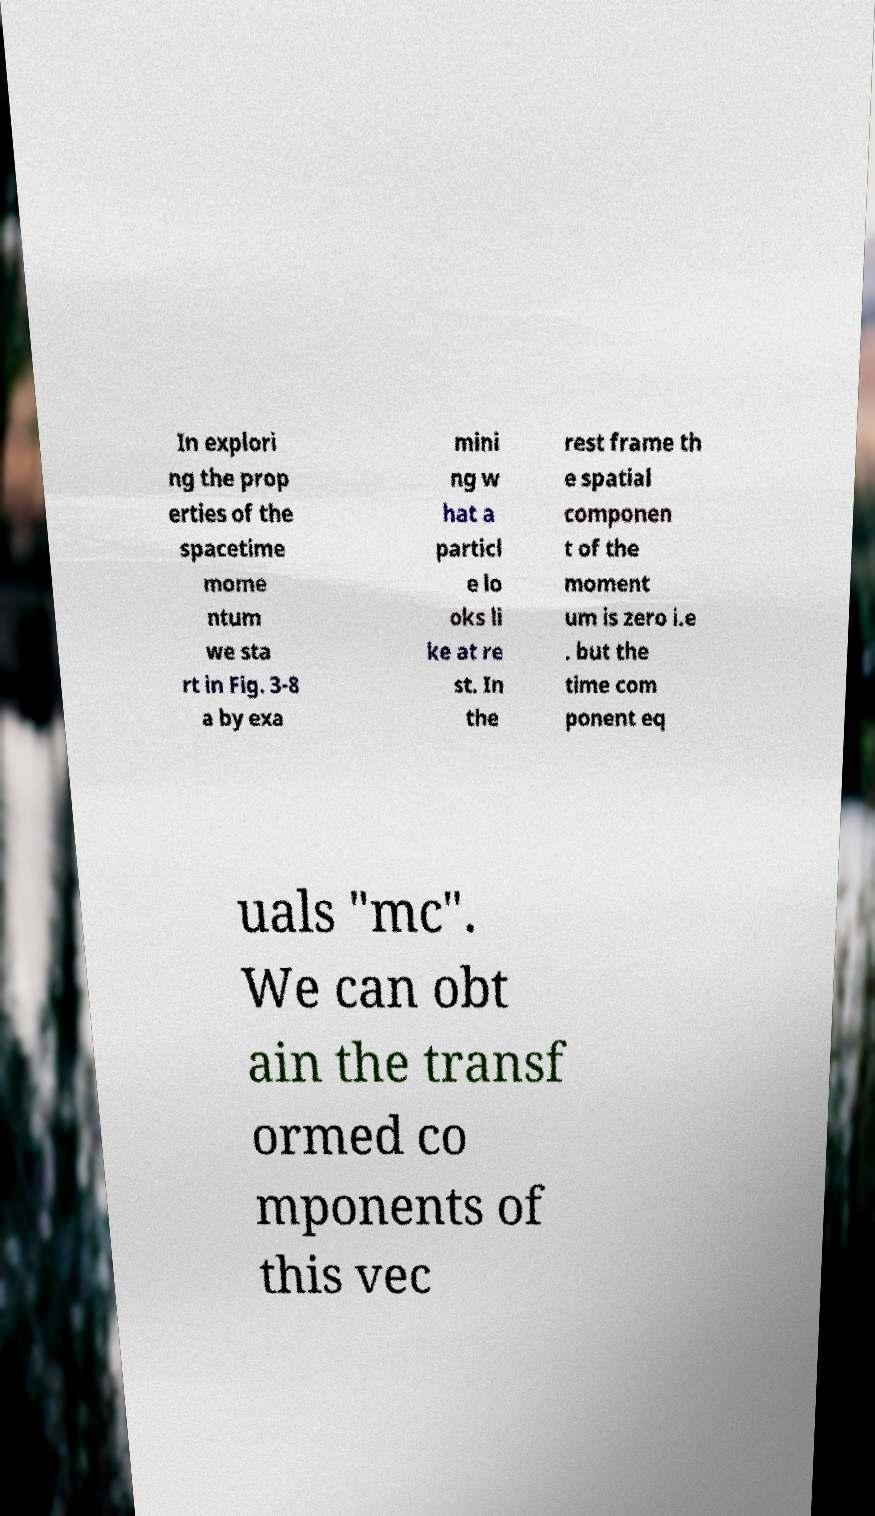There's text embedded in this image that I need extracted. Can you transcribe it verbatim? In explori ng the prop erties of the spacetime mome ntum we sta rt in Fig. 3-8 a by exa mini ng w hat a particl e lo oks li ke at re st. In the rest frame th e spatial componen t of the moment um is zero i.e . but the time com ponent eq uals "mc". We can obt ain the transf ormed co mponents of this vec 